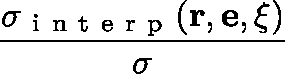Convert formula to latex. <formula><loc_0><loc_0><loc_500><loc_500>\frac { \sigma _ { i n t e r p } ( r , e , \xi ) } { \sigma }</formula> 